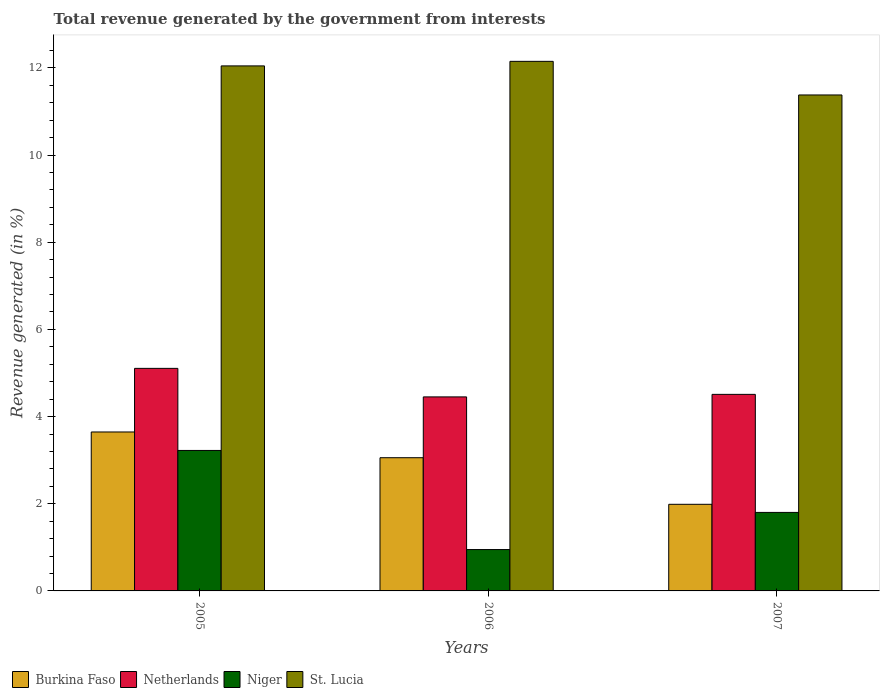How many different coloured bars are there?
Your answer should be compact. 4. Are the number of bars per tick equal to the number of legend labels?
Ensure brevity in your answer.  Yes. Are the number of bars on each tick of the X-axis equal?
Provide a succinct answer. Yes. How many bars are there on the 1st tick from the left?
Your answer should be compact. 4. What is the label of the 1st group of bars from the left?
Your answer should be very brief. 2005. In how many cases, is the number of bars for a given year not equal to the number of legend labels?
Offer a terse response. 0. What is the total revenue generated in Burkina Faso in 2007?
Ensure brevity in your answer.  1.99. Across all years, what is the maximum total revenue generated in Niger?
Your response must be concise. 3.22. Across all years, what is the minimum total revenue generated in Niger?
Offer a terse response. 0.95. In which year was the total revenue generated in Niger maximum?
Give a very brief answer. 2005. What is the total total revenue generated in St. Lucia in the graph?
Your answer should be compact. 35.58. What is the difference between the total revenue generated in Niger in 2006 and that in 2007?
Provide a succinct answer. -0.85. What is the difference between the total revenue generated in Netherlands in 2007 and the total revenue generated in St. Lucia in 2005?
Offer a very short reply. -7.54. What is the average total revenue generated in St. Lucia per year?
Your answer should be compact. 11.86. In the year 2005, what is the difference between the total revenue generated in Niger and total revenue generated in Burkina Faso?
Make the answer very short. -0.42. What is the ratio of the total revenue generated in Netherlands in 2006 to that in 2007?
Make the answer very short. 0.99. Is the total revenue generated in Niger in 2005 less than that in 2006?
Your answer should be compact. No. What is the difference between the highest and the second highest total revenue generated in Niger?
Provide a succinct answer. 1.42. What is the difference between the highest and the lowest total revenue generated in Burkina Faso?
Make the answer very short. 1.66. What does the 1st bar from the left in 2007 represents?
Provide a succinct answer. Burkina Faso. What does the 2nd bar from the right in 2005 represents?
Provide a short and direct response. Niger. Is it the case that in every year, the sum of the total revenue generated in Netherlands and total revenue generated in St. Lucia is greater than the total revenue generated in Burkina Faso?
Offer a terse response. Yes. How many bars are there?
Keep it short and to the point. 12. Are all the bars in the graph horizontal?
Provide a succinct answer. No. How many years are there in the graph?
Keep it short and to the point. 3. What is the difference between two consecutive major ticks on the Y-axis?
Provide a succinct answer. 2. Where does the legend appear in the graph?
Your answer should be very brief. Bottom left. How many legend labels are there?
Ensure brevity in your answer.  4. How are the legend labels stacked?
Your answer should be compact. Horizontal. What is the title of the graph?
Offer a very short reply. Total revenue generated by the government from interests. Does "Cabo Verde" appear as one of the legend labels in the graph?
Make the answer very short. No. What is the label or title of the X-axis?
Your answer should be compact. Years. What is the label or title of the Y-axis?
Ensure brevity in your answer.  Revenue generated (in %). What is the Revenue generated (in %) of Burkina Faso in 2005?
Offer a terse response. 3.65. What is the Revenue generated (in %) of Netherlands in 2005?
Give a very brief answer. 5.11. What is the Revenue generated (in %) of Niger in 2005?
Ensure brevity in your answer.  3.22. What is the Revenue generated (in %) of St. Lucia in 2005?
Your answer should be compact. 12.05. What is the Revenue generated (in %) in Burkina Faso in 2006?
Ensure brevity in your answer.  3.06. What is the Revenue generated (in %) in Netherlands in 2006?
Your answer should be very brief. 4.45. What is the Revenue generated (in %) in Niger in 2006?
Keep it short and to the point. 0.95. What is the Revenue generated (in %) in St. Lucia in 2006?
Your answer should be very brief. 12.15. What is the Revenue generated (in %) of Burkina Faso in 2007?
Your answer should be very brief. 1.99. What is the Revenue generated (in %) in Netherlands in 2007?
Give a very brief answer. 4.51. What is the Revenue generated (in %) in Niger in 2007?
Make the answer very short. 1.8. What is the Revenue generated (in %) in St. Lucia in 2007?
Ensure brevity in your answer.  11.38. Across all years, what is the maximum Revenue generated (in %) of Burkina Faso?
Keep it short and to the point. 3.65. Across all years, what is the maximum Revenue generated (in %) in Netherlands?
Give a very brief answer. 5.11. Across all years, what is the maximum Revenue generated (in %) in Niger?
Your answer should be compact. 3.22. Across all years, what is the maximum Revenue generated (in %) in St. Lucia?
Your answer should be very brief. 12.15. Across all years, what is the minimum Revenue generated (in %) in Burkina Faso?
Make the answer very short. 1.99. Across all years, what is the minimum Revenue generated (in %) in Netherlands?
Offer a terse response. 4.45. Across all years, what is the minimum Revenue generated (in %) in Niger?
Provide a short and direct response. 0.95. Across all years, what is the minimum Revenue generated (in %) in St. Lucia?
Give a very brief answer. 11.38. What is the total Revenue generated (in %) of Burkina Faso in the graph?
Keep it short and to the point. 8.69. What is the total Revenue generated (in %) in Netherlands in the graph?
Your answer should be very brief. 14.07. What is the total Revenue generated (in %) in Niger in the graph?
Keep it short and to the point. 5.97. What is the total Revenue generated (in %) of St. Lucia in the graph?
Ensure brevity in your answer.  35.58. What is the difference between the Revenue generated (in %) in Burkina Faso in 2005 and that in 2006?
Give a very brief answer. 0.59. What is the difference between the Revenue generated (in %) of Netherlands in 2005 and that in 2006?
Provide a succinct answer. 0.65. What is the difference between the Revenue generated (in %) of Niger in 2005 and that in 2006?
Ensure brevity in your answer.  2.27. What is the difference between the Revenue generated (in %) of St. Lucia in 2005 and that in 2006?
Your response must be concise. -0.1. What is the difference between the Revenue generated (in %) of Burkina Faso in 2005 and that in 2007?
Ensure brevity in your answer.  1.66. What is the difference between the Revenue generated (in %) in Netherlands in 2005 and that in 2007?
Your answer should be very brief. 0.6. What is the difference between the Revenue generated (in %) in Niger in 2005 and that in 2007?
Your response must be concise. 1.42. What is the difference between the Revenue generated (in %) of St. Lucia in 2005 and that in 2007?
Your answer should be very brief. 0.67. What is the difference between the Revenue generated (in %) in Burkina Faso in 2006 and that in 2007?
Your answer should be compact. 1.07. What is the difference between the Revenue generated (in %) in Netherlands in 2006 and that in 2007?
Provide a succinct answer. -0.06. What is the difference between the Revenue generated (in %) in Niger in 2006 and that in 2007?
Give a very brief answer. -0.85. What is the difference between the Revenue generated (in %) in St. Lucia in 2006 and that in 2007?
Your answer should be very brief. 0.77. What is the difference between the Revenue generated (in %) of Burkina Faso in 2005 and the Revenue generated (in %) of Netherlands in 2006?
Provide a succinct answer. -0.8. What is the difference between the Revenue generated (in %) in Burkina Faso in 2005 and the Revenue generated (in %) in Niger in 2006?
Offer a terse response. 2.7. What is the difference between the Revenue generated (in %) in Burkina Faso in 2005 and the Revenue generated (in %) in St. Lucia in 2006?
Offer a terse response. -8.5. What is the difference between the Revenue generated (in %) in Netherlands in 2005 and the Revenue generated (in %) in Niger in 2006?
Provide a succinct answer. 4.16. What is the difference between the Revenue generated (in %) of Netherlands in 2005 and the Revenue generated (in %) of St. Lucia in 2006?
Keep it short and to the point. -7.04. What is the difference between the Revenue generated (in %) of Niger in 2005 and the Revenue generated (in %) of St. Lucia in 2006?
Give a very brief answer. -8.93. What is the difference between the Revenue generated (in %) of Burkina Faso in 2005 and the Revenue generated (in %) of Netherlands in 2007?
Your response must be concise. -0.86. What is the difference between the Revenue generated (in %) in Burkina Faso in 2005 and the Revenue generated (in %) in Niger in 2007?
Provide a succinct answer. 1.85. What is the difference between the Revenue generated (in %) in Burkina Faso in 2005 and the Revenue generated (in %) in St. Lucia in 2007?
Give a very brief answer. -7.73. What is the difference between the Revenue generated (in %) in Netherlands in 2005 and the Revenue generated (in %) in Niger in 2007?
Ensure brevity in your answer.  3.3. What is the difference between the Revenue generated (in %) in Netherlands in 2005 and the Revenue generated (in %) in St. Lucia in 2007?
Keep it short and to the point. -6.27. What is the difference between the Revenue generated (in %) of Niger in 2005 and the Revenue generated (in %) of St. Lucia in 2007?
Offer a terse response. -8.16. What is the difference between the Revenue generated (in %) of Burkina Faso in 2006 and the Revenue generated (in %) of Netherlands in 2007?
Your response must be concise. -1.45. What is the difference between the Revenue generated (in %) of Burkina Faso in 2006 and the Revenue generated (in %) of Niger in 2007?
Ensure brevity in your answer.  1.25. What is the difference between the Revenue generated (in %) in Burkina Faso in 2006 and the Revenue generated (in %) in St. Lucia in 2007?
Provide a short and direct response. -8.32. What is the difference between the Revenue generated (in %) of Netherlands in 2006 and the Revenue generated (in %) of Niger in 2007?
Your answer should be compact. 2.65. What is the difference between the Revenue generated (in %) in Netherlands in 2006 and the Revenue generated (in %) in St. Lucia in 2007?
Make the answer very short. -6.93. What is the difference between the Revenue generated (in %) of Niger in 2006 and the Revenue generated (in %) of St. Lucia in 2007?
Ensure brevity in your answer.  -10.43. What is the average Revenue generated (in %) in Burkina Faso per year?
Your response must be concise. 2.9. What is the average Revenue generated (in %) in Netherlands per year?
Offer a very short reply. 4.69. What is the average Revenue generated (in %) in Niger per year?
Provide a short and direct response. 1.99. What is the average Revenue generated (in %) of St. Lucia per year?
Make the answer very short. 11.86. In the year 2005, what is the difference between the Revenue generated (in %) of Burkina Faso and Revenue generated (in %) of Netherlands?
Provide a short and direct response. -1.46. In the year 2005, what is the difference between the Revenue generated (in %) of Burkina Faso and Revenue generated (in %) of Niger?
Your answer should be compact. 0.42. In the year 2005, what is the difference between the Revenue generated (in %) of Burkina Faso and Revenue generated (in %) of St. Lucia?
Offer a very short reply. -8.4. In the year 2005, what is the difference between the Revenue generated (in %) in Netherlands and Revenue generated (in %) in Niger?
Provide a short and direct response. 1.88. In the year 2005, what is the difference between the Revenue generated (in %) of Netherlands and Revenue generated (in %) of St. Lucia?
Your answer should be compact. -6.94. In the year 2005, what is the difference between the Revenue generated (in %) of Niger and Revenue generated (in %) of St. Lucia?
Offer a very short reply. -8.82. In the year 2006, what is the difference between the Revenue generated (in %) in Burkina Faso and Revenue generated (in %) in Netherlands?
Keep it short and to the point. -1.4. In the year 2006, what is the difference between the Revenue generated (in %) of Burkina Faso and Revenue generated (in %) of Niger?
Provide a short and direct response. 2.11. In the year 2006, what is the difference between the Revenue generated (in %) of Burkina Faso and Revenue generated (in %) of St. Lucia?
Offer a very short reply. -9.09. In the year 2006, what is the difference between the Revenue generated (in %) of Netherlands and Revenue generated (in %) of Niger?
Keep it short and to the point. 3.5. In the year 2006, what is the difference between the Revenue generated (in %) in Netherlands and Revenue generated (in %) in St. Lucia?
Keep it short and to the point. -7.7. In the year 2006, what is the difference between the Revenue generated (in %) in Niger and Revenue generated (in %) in St. Lucia?
Your answer should be compact. -11.2. In the year 2007, what is the difference between the Revenue generated (in %) in Burkina Faso and Revenue generated (in %) in Netherlands?
Keep it short and to the point. -2.52. In the year 2007, what is the difference between the Revenue generated (in %) in Burkina Faso and Revenue generated (in %) in Niger?
Offer a very short reply. 0.19. In the year 2007, what is the difference between the Revenue generated (in %) of Burkina Faso and Revenue generated (in %) of St. Lucia?
Make the answer very short. -9.39. In the year 2007, what is the difference between the Revenue generated (in %) of Netherlands and Revenue generated (in %) of Niger?
Provide a short and direct response. 2.71. In the year 2007, what is the difference between the Revenue generated (in %) of Netherlands and Revenue generated (in %) of St. Lucia?
Offer a terse response. -6.87. In the year 2007, what is the difference between the Revenue generated (in %) of Niger and Revenue generated (in %) of St. Lucia?
Your response must be concise. -9.58. What is the ratio of the Revenue generated (in %) of Burkina Faso in 2005 to that in 2006?
Your answer should be very brief. 1.19. What is the ratio of the Revenue generated (in %) of Netherlands in 2005 to that in 2006?
Offer a terse response. 1.15. What is the ratio of the Revenue generated (in %) of Niger in 2005 to that in 2006?
Offer a terse response. 3.4. What is the ratio of the Revenue generated (in %) of St. Lucia in 2005 to that in 2006?
Give a very brief answer. 0.99. What is the ratio of the Revenue generated (in %) of Burkina Faso in 2005 to that in 2007?
Provide a succinct answer. 1.83. What is the ratio of the Revenue generated (in %) of Netherlands in 2005 to that in 2007?
Offer a terse response. 1.13. What is the ratio of the Revenue generated (in %) in Niger in 2005 to that in 2007?
Offer a terse response. 1.79. What is the ratio of the Revenue generated (in %) of St. Lucia in 2005 to that in 2007?
Provide a short and direct response. 1.06. What is the ratio of the Revenue generated (in %) in Burkina Faso in 2006 to that in 2007?
Give a very brief answer. 1.54. What is the ratio of the Revenue generated (in %) of Netherlands in 2006 to that in 2007?
Give a very brief answer. 0.99. What is the ratio of the Revenue generated (in %) of Niger in 2006 to that in 2007?
Give a very brief answer. 0.53. What is the ratio of the Revenue generated (in %) of St. Lucia in 2006 to that in 2007?
Make the answer very short. 1.07. What is the difference between the highest and the second highest Revenue generated (in %) in Burkina Faso?
Offer a very short reply. 0.59. What is the difference between the highest and the second highest Revenue generated (in %) of Netherlands?
Your answer should be compact. 0.6. What is the difference between the highest and the second highest Revenue generated (in %) in Niger?
Make the answer very short. 1.42. What is the difference between the highest and the second highest Revenue generated (in %) in St. Lucia?
Provide a succinct answer. 0.1. What is the difference between the highest and the lowest Revenue generated (in %) in Burkina Faso?
Ensure brevity in your answer.  1.66. What is the difference between the highest and the lowest Revenue generated (in %) of Netherlands?
Keep it short and to the point. 0.65. What is the difference between the highest and the lowest Revenue generated (in %) in Niger?
Offer a terse response. 2.27. What is the difference between the highest and the lowest Revenue generated (in %) of St. Lucia?
Offer a very short reply. 0.77. 